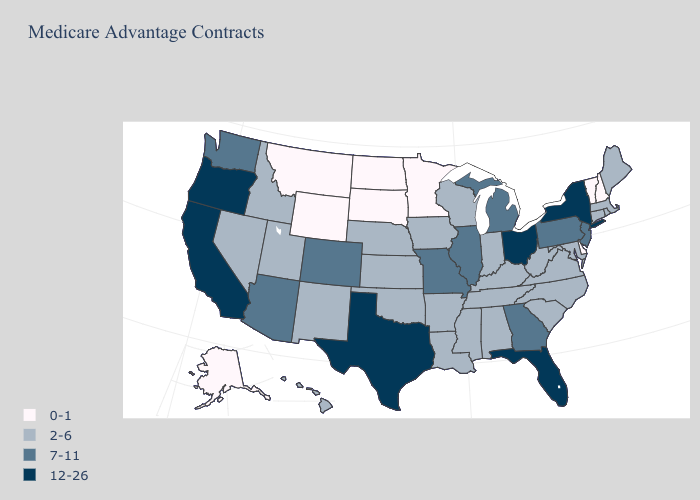What is the lowest value in the Northeast?
Answer briefly. 0-1. Name the states that have a value in the range 7-11?
Short answer required. Arizona, Colorado, Georgia, Illinois, Michigan, Missouri, New Jersey, Pennsylvania, Washington. What is the lowest value in the USA?
Short answer required. 0-1. What is the lowest value in the West?
Keep it brief. 0-1. Which states hav the highest value in the MidWest?
Be succinct. Ohio. Does Mississippi have the same value as South Dakota?
Give a very brief answer. No. Does the map have missing data?
Be succinct. No. What is the highest value in states that border Virginia?
Give a very brief answer. 2-6. What is the value of Ohio?
Short answer required. 12-26. Name the states that have a value in the range 2-6?
Be succinct. Alabama, Arkansas, Connecticut, Hawaii, Iowa, Idaho, Indiana, Kansas, Kentucky, Louisiana, Massachusetts, Maryland, Maine, Mississippi, North Carolina, Nebraska, New Mexico, Nevada, Oklahoma, Rhode Island, South Carolina, Tennessee, Utah, Virginia, Wisconsin, West Virginia. What is the lowest value in states that border Missouri?
Write a very short answer. 2-6. What is the lowest value in states that border North Dakota?
Quick response, please. 0-1. Name the states that have a value in the range 12-26?
Short answer required. California, Florida, New York, Ohio, Oregon, Texas. Does Texas have the highest value in the USA?
Write a very short answer. Yes. Does Minnesota have the lowest value in the USA?
Be succinct. Yes. 